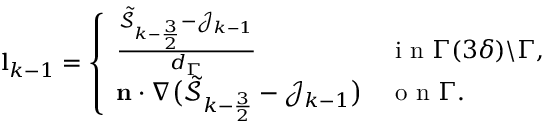Convert formula to latex. <formula><loc_0><loc_0><loc_500><loc_500>\begin{array} { r } { l _ { k - 1 } = \left \{ \begin{array} { l l } { \frac { \tilde { \mathcal { S } } _ { k - \frac { 3 } { 2 } } - \mathcal { J } _ { k - 1 } } { d _ { \Gamma } } } & { i n \Gamma ( 3 \delta ) \ \Gamma , } \\ { n \cdot \nabla \left ( \tilde { \mathcal { S } } _ { k - \frac { 3 } { 2 } } - \mathcal { J } _ { k - 1 } \right ) } & { o n \Gamma . } \end{array} } \end{array}</formula> 